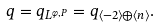Convert formula to latex. <formula><loc_0><loc_0><loc_500><loc_500>q = q _ { L ^ { \varphi , P } } = q _ { \langle - 2 \rangle \oplus \langle n \rangle } .</formula> 